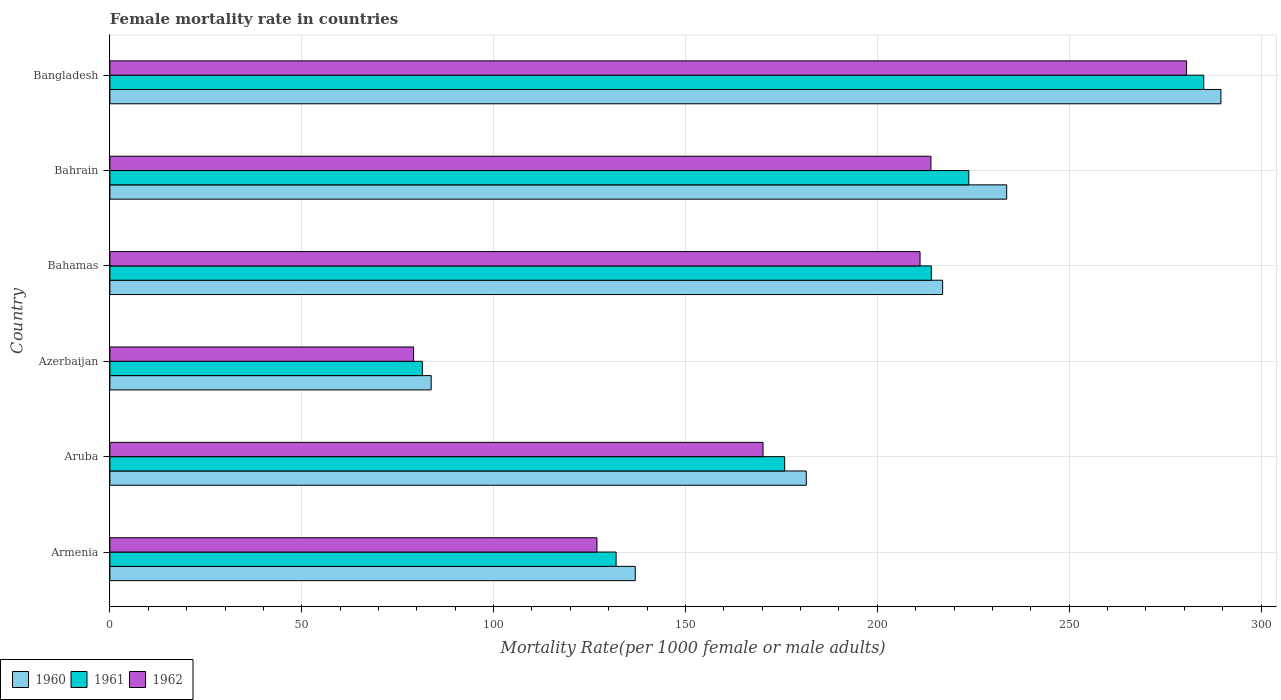How many bars are there on the 4th tick from the top?
Give a very brief answer. 3. How many bars are there on the 3rd tick from the bottom?
Your answer should be compact. 3. What is the label of the 6th group of bars from the top?
Offer a terse response. Armenia. In how many cases, is the number of bars for a given country not equal to the number of legend labels?
Provide a short and direct response. 0. What is the female mortality rate in 1962 in Bahamas?
Offer a very short reply. 211.13. Across all countries, what is the maximum female mortality rate in 1961?
Keep it short and to the point. 285.07. Across all countries, what is the minimum female mortality rate in 1960?
Your answer should be compact. 83.73. In which country was the female mortality rate in 1962 minimum?
Your response must be concise. Azerbaijan. What is the total female mortality rate in 1961 in the graph?
Provide a succinct answer. 1112.19. What is the difference between the female mortality rate in 1960 in Azerbaijan and that in Bangladesh?
Provide a short and direct response. -205.82. What is the difference between the female mortality rate in 1960 in Bahamas and the female mortality rate in 1962 in Armenia?
Ensure brevity in your answer.  90.08. What is the average female mortality rate in 1961 per country?
Offer a terse response. 185.37. What is the difference between the female mortality rate in 1962 and female mortality rate in 1960 in Bangladesh?
Make the answer very short. -8.96. In how many countries, is the female mortality rate in 1962 greater than 20 ?
Your response must be concise. 6. What is the ratio of the female mortality rate in 1962 in Azerbaijan to that in Bahamas?
Provide a short and direct response. 0.37. Is the female mortality rate in 1960 in Armenia less than that in Azerbaijan?
Your answer should be compact. No. What is the difference between the highest and the second highest female mortality rate in 1962?
Provide a short and direct response. 66.62. What is the difference between the highest and the lowest female mortality rate in 1961?
Your response must be concise. 203.64. Is the sum of the female mortality rate in 1962 in Armenia and Azerbaijan greater than the maximum female mortality rate in 1960 across all countries?
Provide a short and direct response. No. Are all the bars in the graph horizontal?
Your answer should be compact. Yes. How many countries are there in the graph?
Ensure brevity in your answer.  6. What is the difference between two consecutive major ticks on the X-axis?
Your answer should be compact. 50. Does the graph contain any zero values?
Offer a terse response. No. Where does the legend appear in the graph?
Give a very brief answer. Bottom left. What is the title of the graph?
Your answer should be compact. Female mortality rate in countries. What is the label or title of the X-axis?
Provide a short and direct response. Mortality Rate(per 1000 female or male adults). What is the label or title of the Y-axis?
Make the answer very short. Country. What is the Mortality Rate(per 1000 female or male adults) of 1960 in Armenia?
Offer a very short reply. 136.92. What is the Mortality Rate(per 1000 female or male adults) of 1961 in Armenia?
Make the answer very short. 131.93. What is the Mortality Rate(per 1000 female or male adults) of 1962 in Armenia?
Keep it short and to the point. 126.93. What is the Mortality Rate(per 1000 female or male adults) of 1960 in Aruba?
Provide a succinct answer. 181.48. What is the Mortality Rate(per 1000 female or male adults) in 1961 in Aruba?
Ensure brevity in your answer.  175.85. What is the Mortality Rate(per 1000 female or male adults) of 1962 in Aruba?
Offer a very short reply. 170.21. What is the Mortality Rate(per 1000 female or male adults) in 1960 in Azerbaijan?
Your answer should be compact. 83.73. What is the Mortality Rate(per 1000 female or male adults) of 1961 in Azerbaijan?
Ensure brevity in your answer.  81.43. What is the Mortality Rate(per 1000 female or male adults) in 1962 in Azerbaijan?
Ensure brevity in your answer.  79.14. What is the Mortality Rate(per 1000 female or male adults) of 1960 in Bahamas?
Give a very brief answer. 217.02. What is the Mortality Rate(per 1000 female or male adults) in 1961 in Bahamas?
Offer a terse response. 214.07. What is the Mortality Rate(per 1000 female or male adults) of 1962 in Bahamas?
Offer a very short reply. 211.13. What is the Mortality Rate(per 1000 female or male adults) in 1960 in Bahrain?
Your response must be concise. 233.71. What is the Mortality Rate(per 1000 female or male adults) in 1961 in Bahrain?
Provide a succinct answer. 223.84. What is the Mortality Rate(per 1000 female or male adults) of 1962 in Bahrain?
Offer a very short reply. 213.97. What is the Mortality Rate(per 1000 female or male adults) of 1960 in Bangladesh?
Keep it short and to the point. 289.55. What is the Mortality Rate(per 1000 female or male adults) in 1961 in Bangladesh?
Provide a short and direct response. 285.07. What is the Mortality Rate(per 1000 female or male adults) of 1962 in Bangladesh?
Keep it short and to the point. 280.59. Across all countries, what is the maximum Mortality Rate(per 1000 female or male adults) of 1960?
Provide a short and direct response. 289.55. Across all countries, what is the maximum Mortality Rate(per 1000 female or male adults) of 1961?
Offer a terse response. 285.07. Across all countries, what is the maximum Mortality Rate(per 1000 female or male adults) in 1962?
Your response must be concise. 280.59. Across all countries, what is the minimum Mortality Rate(per 1000 female or male adults) in 1960?
Offer a terse response. 83.73. Across all countries, what is the minimum Mortality Rate(per 1000 female or male adults) in 1961?
Your answer should be very brief. 81.43. Across all countries, what is the minimum Mortality Rate(per 1000 female or male adults) in 1962?
Provide a succinct answer. 79.14. What is the total Mortality Rate(per 1000 female or male adults) of 1960 in the graph?
Give a very brief answer. 1142.41. What is the total Mortality Rate(per 1000 female or male adults) in 1961 in the graph?
Make the answer very short. 1112.19. What is the total Mortality Rate(per 1000 female or male adults) in 1962 in the graph?
Offer a very short reply. 1081.97. What is the difference between the Mortality Rate(per 1000 female or male adults) in 1960 in Armenia and that in Aruba?
Your response must be concise. -44.57. What is the difference between the Mortality Rate(per 1000 female or male adults) in 1961 in Armenia and that in Aruba?
Offer a very short reply. -43.92. What is the difference between the Mortality Rate(per 1000 female or male adults) in 1962 in Armenia and that in Aruba?
Provide a short and direct response. -43.28. What is the difference between the Mortality Rate(per 1000 female or male adults) of 1960 in Armenia and that in Azerbaijan?
Your answer should be very brief. 53.19. What is the difference between the Mortality Rate(per 1000 female or male adults) of 1961 in Armenia and that in Azerbaijan?
Your answer should be very brief. 50.49. What is the difference between the Mortality Rate(per 1000 female or male adults) of 1962 in Armenia and that in Azerbaijan?
Offer a very short reply. 47.8. What is the difference between the Mortality Rate(per 1000 female or male adults) of 1960 in Armenia and that in Bahamas?
Provide a succinct answer. -80.1. What is the difference between the Mortality Rate(per 1000 female or male adults) of 1961 in Armenia and that in Bahamas?
Provide a short and direct response. -82.15. What is the difference between the Mortality Rate(per 1000 female or male adults) of 1962 in Armenia and that in Bahamas?
Offer a very short reply. -84.2. What is the difference between the Mortality Rate(per 1000 female or male adults) in 1960 in Armenia and that in Bahrain?
Your response must be concise. -96.8. What is the difference between the Mortality Rate(per 1000 female or male adults) of 1961 in Armenia and that in Bahrain?
Provide a succinct answer. -91.92. What is the difference between the Mortality Rate(per 1000 female or male adults) in 1962 in Armenia and that in Bahrain?
Ensure brevity in your answer.  -87.04. What is the difference between the Mortality Rate(per 1000 female or male adults) in 1960 in Armenia and that in Bangladesh?
Your response must be concise. -152.63. What is the difference between the Mortality Rate(per 1000 female or male adults) in 1961 in Armenia and that in Bangladesh?
Offer a very short reply. -153.14. What is the difference between the Mortality Rate(per 1000 female or male adults) of 1962 in Armenia and that in Bangladesh?
Offer a terse response. -153.66. What is the difference between the Mortality Rate(per 1000 female or male adults) of 1960 in Aruba and that in Azerbaijan?
Give a very brief answer. 97.76. What is the difference between the Mortality Rate(per 1000 female or male adults) of 1961 in Aruba and that in Azerbaijan?
Make the answer very short. 94.42. What is the difference between the Mortality Rate(per 1000 female or male adults) in 1962 in Aruba and that in Azerbaijan?
Provide a succinct answer. 91.08. What is the difference between the Mortality Rate(per 1000 female or male adults) in 1960 in Aruba and that in Bahamas?
Offer a very short reply. -35.53. What is the difference between the Mortality Rate(per 1000 female or male adults) of 1961 in Aruba and that in Bahamas?
Provide a short and direct response. -38.23. What is the difference between the Mortality Rate(per 1000 female or male adults) of 1962 in Aruba and that in Bahamas?
Give a very brief answer. -40.92. What is the difference between the Mortality Rate(per 1000 female or male adults) of 1960 in Aruba and that in Bahrain?
Your response must be concise. -52.23. What is the difference between the Mortality Rate(per 1000 female or male adults) of 1961 in Aruba and that in Bahrain?
Give a very brief answer. -47.99. What is the difference between the Mortality Rate(per 1000 female or male adults) in 1962 in Aruba and that in Bahrain?
Keep it short and to the point. -43.76. What is the difference between the Mortality Rate(per 1000 female or male adults) of 1960 in Aruba and that in Bangladesh?
Ensure brevity in your answer.  -108.06. What is the difference between the Mortality Rate(per 1000 female or male adults) in 1961 in Aruba and that in Bangladesh?
Ensure brevity in your answer.  -109.22. What is the difference between the Mortality Rate(per 1000 female or male adults) of 1962 in Aruba and that in Bangladesh?
Ensure brevity in your answer.  -110.38. What is the difference between the Mortality Rate(per 1000 female or male adults) of 1960 in Azerbaijan and that in Bahamas?
Give a very brief answer. -133.29. What is the difference between the Mortality Rate(per 1000 female or male adults) in 1961 in Azerbaijan and that in Bahamas?
Provide a succinct answer. -132.64. What is the difference between the Mortality Rate(per 1000 female or male adults) of 1962 in Azerbaijan and that in Bahamas?
Your response must be concise. -131.99. What is the difference between the Mortality Rate(per 1000 female or male adults) in 1960 in Azerbaijan and that in Bahrain?
Offer a terse response. -149.99. What is the difference between the Mortality Rate(per 1000 female or male adults) of 1961 in Azerbaijan and that in Bahrain?
Ensure brevity in your answer.  -142.41. What is the difference between the Mortality Rate(per 1000 female or male adults) in 1962 in Azerbaijan and that in Bahrain?
Ensure brevity in your answer.  -134.83. What is the difference between the Mortality Rate(per 1000 female or male adults) of 1960 in Azerbaijan and that in Bangladesh?
Your response must be concise. -205.82. What is the difference between the Mortality Rate(per 1000 female or male adults) in 1961 in Azerbaijan and that in Bangladesh?
Provide a short and direct response. -203.64. What is the difference between the Mortality Rate(per 1000 female or male adults) in 1962 in Azerbaijan and that in Bangladesh?
Your answer should be very brief. -201.45. What is the difference between the Mortality Rate(per 1000 female or male adults) of 1960 in Bahamas and that in Bahrain?
Offer a very short reply. -16.7. What is the difference between the Mortality Rate(per 1000 female or male adults) of 1961 in Bahamas and that in Bahrain?
Offer a terse response. -9.77. What is the difference between the Mortality Rate(per 1000 female or male adults) of 1962 in Bahamas and that in Bahrain?
Give a very brief answer. -2.84. What is the difference between the Mortality Rate(per 1000 female or male adults) of 1960 in Bahamas and that in Bangladesh?
Your response must be concise. -72.53. What is the difference between the Mortality Rate(per 1000 female or male adults) in 1961 in Bahamas and that in Bangladesh?
Your answer should be compact. -70.99. What is the difference between the Mortality Rate(per 1000 female or male adults) in 1962 in Bahamas and that in Bangladesh?
Keep it short and to the point. -69.46. What is the difference between the Mortality Rate(per 1000 female or male adults) in 1960 in Bahrain and that in Bangladesh?
Offer a very short reply. -55.84. What is the difference between the Mortality Rate(per 1000 female or male adults) in 1961 in Bahrain and that in Bangladesh?
Keep it short and to the point. -61.23. What is the difference between the Mortality Rate(per 1000 female or male adults) of 1962 in Bahrain and that in Bangladesh?
Provide a succinct answer. -66.62. What is the difference between the Mortality Rate(per 1000 female or male adults) of 1960 in Armenia and the Mortality Rate(per 1000 female or male adults) of 1961 in Aruba?
Offer a very short reply. -38.93. What is the difference between the Mortality Rate(per 1000 female or male adults) of 1960 in Armenia and the Mortality Rate(per 1000 female or male adults) of 1962 in Aruba?
Your response must be concise. -33.3. What is the difference between the Mortality Rate(per 1000 female or male adults) in 1961 in Armenia and the Mortality Rate(per 1000 female or male adults) in 1962 in Aruba?
Provide a short and direct response. -38.29. What is the difference between the Mortality Rate(per 1000 female or male adults) in 1960 in Armenia and the Mortality Rate(per 1000 female or male adults) in 1961 in Azerbaijan?
Offer a very short reply. 55.48. What is the difference between the Mortality Rate(per 1000 female or male adults) of 1960 in Armenia and the Mortality Rate(per 1000 female or male adults) of 1962 in Azerbaijan?
Ensure brevity in your answer.  57.78. What is the difference between the Mortality Rate(per 1000 female or male adults) of 1961 in Armenia and the Mortality Rate(per 1000 female or male adults) of 1962 in Azerbaijan?
Your response must be concise. 52.79. What is the difference between the Mortality Rate(per 1000 female or male adults) in 1960 in Armenia and the Mortality Rate(per 1000 female or male adults) in 1961 in Bahamas?
Your answer should be very brief. -77.16. What is the difference between the Mortality Rate(per 1000 female or male adults) of 1960 in Armenia and the Mortality Rate(per 1000 female or male adults) of 1962 in Bahamas?
Offer a very short reply. -74.22. What is the difference between the Mortality Rate(per 1000 female or male adults) of 1961 in Armenia and the Mortality Rate(per 1000 female or male adults) of 1962 in Bahamas?
Offer a very short reply. -79.21. What is the difference between the Mortality Rate(per 1000 female or male adults) of 1960 in Armenia and the Mortality Rate(per 1000 female or male adults) of 1961 in Bahrain?
Provide a short and direct response. -86.92. What is the difference between the Mortality Rate(per 1000 female or male adults) of 1960 in Armenia and the Mortality Rate(per 1000 female or male adults) of 1962 in Bahrain?
Offer a very short reply. -77.05. What is the difference between the Mortality Rate(per 1000 female or male adults) of 1961 in Armenia and the Mortality Rate(per 1000 female or male adults) of 1962 in Bahrain?
Your answer should be very brief. -82.04. What is the difference between the Mortality Rate(per 1000 female or male adults) of 1960 in Armenia and the Mortality Rate(per 1000 female or male adults) of 1961 in Bangladesh?
Your answer should be compact. -148.15. What is the difference between the Mortality Rate(per 1000 female or male adults) of 1960 in Armenia and the Mortality Rate(per 1000 female or male adults) of 1962 in Bangladesh?
Ensure brevity in your answer.  -143.67. What is the difference between the Mortality Rate(per 1000 female or male adults) in 1961 in Armenia and the Mortality Rate(per 1000 female or male adults) in 1962 in Bangladesh?
Your answer should be very brief. -148.66. What is the difference between the Mortality Rate(per 1000 female or male adults) in 1960 in Aruba and the Mortality Rate(per 1000 female or male adults) in 1961 in Azerbaijan?
Provide a short and direct response. 100.05. What is the difference between the Mortality Rate(per 1000 female or male adults) of 1960 in Aruba and the Mortality Rate(per 1000 female or male adults) of 1962 in Azerbaijan?
Keep it short and to the point. 102.35. What is the difference between the Mortality Rate(per 1000 female or male adults) in 1961 in Aruba and the Mortality Rate(per 1000 female or male adults) in 1962 in Azerbaijan?
Provide a succinct answer. 96.71. What is the difference between the Mortality Rate(per 1000 female or male adults) of 1960 in Aruba and the Mortality Rate(per 1000 female or male adults) of 1961 in Bahamas?
Keep it short and to the point. -32.59. What is the difference between the Mortality Rate(per 1000 female or male adults) in 1960 in Aruba and the Mortality Rate(per 1000 female or male adults) in 1962 in Bahamas?
Provide a short and direct response. -29.65. What is the difference between the Mortality Rate(per 1000 female or male adults) of 1961 in Aruba and the Mortality Rate(per 1000 female or male adults) of 1962 in Bahamas?
Your answer should be compact. -35.28. What is the difference between the Mortality Rate(per 1000 female or male adults) in 1960 in Aruba and the Mortality Rate(per 1000 female or male adults) in 1961 in Bahrain?
Your response must be concise. -42.36. What is the difference between the Mortality Rate(per 1000 female or male adults) in 1960 in Aruba and the Mortality Rate(per 1000 female or male adults) in 1962 in Bahrain?
Make the answer very short. -32.48. What is the difference between the Mortality Rate(per 1000 female or male adults) in 1961 in Aruba and the Mortality Rate(per 1000 female or male adults) in 1962 in Bahrain?
Provide a short and direct response. -38.12. What is the difference between the Mortality Rate(per 1000 female or male adults) in 1960 in Aruba and the Mortality Rate(per 1000 female or male adults) in 1961 in Bangladesh?
Offer a terse response. -103.58. What is the difference between the Mortality Rate(per 1000 female or male adults) of 1960 in Aruba and the Mortality Rate(per 1000 female or male adults) of 1962 in Bangladesh?
Provide a short and direct response. -99.1. What is the difference between the Mortality Rate(per 1000 female or male adults) of 1961 in Aruba and the Mortality Rate(per 1000 female or male adults) of 1962 in Bangladesh?
Ensure brevity in your answer.  -104.74. What is the difference between the Mortality Rate(per 1000 female or male adults) in 1960 in Azerbaijan and the Mortality Rate(per 1000 female or male adults) in 1961 in Bahamas?
Offer a very short reply. -130.35. What is the difference between the Mortality Rate(per 1000 female or male adults) in 1960 in Azerbaijan and the Mortality Rate(per 1000 female or male adults) in 1962 in Bahamas?
Give a very brief answer. -127.4. What is the difference between the Mortality Rate(per 1000 female or male adults) of 1961 in Azerbaijan and the Mortality Rate(per 1000 female or male adults) of 1962 in Bahamas?
Ensure brevity in your answer.  -129.7. What is the difference between the Mortality Rate(per 1000 female or male adults) in 1960 in Azerbaijan and the Mortality Rate(per 1000 female or male adults) in 1961 in Bahrain?
Your answer should be compact. -140.11. What is the difference between the Mortality Rate(per 1000 female or male adults) in 1960 in Azerbaijan and the Mortality Rate(per 1000 female or male adults) in 1962 in Bahrain?
Provide a succinct answer. -130.24. What is the difference between the Mortality Rate(per 1000 female or male adults) of 1961 in Azerbaijan and the Mortality Rate(per 1000 female or male adults) of 1962 in Bahrain?
Keep it short and to the point. -132.54. What is the difference between the Mortality Rate(per 1000 female or male adults) in 1960 in Azerbaijan and the Mortality Rate(per 1000 female or male adults) in 1961 in Bangladesh?
Keep it short and to the point. -201.34. What is the difference between the Mortality Rate(per 1000 female or male adults) of 1960 in Azerbaijan and the Mortality Rate(per 1000 female or male adults) of 1962 in Bangladesh?
Give a very brief answer. -196.86. What is the difference between the Mortality Rate(per 1000 female or male adults) of 1961 in Azerbaijan and the Mortality Rate(per 1000 female or male adults) of 1962 in Bangladesh?
Your answer should be compact. -199.16. What is the difference between the Mortality Rate(per 1000 female or male adults) in 1960 in Bahamas and the Mortality Rate(per 1000 female or male adults) in 1961 in Bahrain?
Your answer should be compact. -6.82. What is the difference between the Mortality Rate(per 1000 female or male adults) of 1960 in Bahamas and the Mortality Rate(per 1000 female or male adults) of 1962 in Bahrain?
Ensure brevity in your answer.  3.05. What is the difference between the Mortality Rate(per 1000 female or male adults) of 1961 in Bahamas and the Mortality Rate(per 1000 female or male adults) of 1962 in Bahrain?
Offer a terse response. 0.11. What is the difference between the Mortality Rate(per 1000 female or male adults) of 1960 in Bahamas and the Mortality Rate(per 1000 female or male adults) of 1961 in Bangladesh?
Provide a short and direct response. -68.05. What is the difference between the Mortality Rate(per 1000 female or male adults) in 1960 in Bahamas and the Mortality Rate(per 1000 female or male adults) in 1962 in Bangladesh?
Make the answer very short. -63.57. What is the difference between the Mortality Rate(per 1000 female or male adults) of 1961 in Bahamas and the Mortality Rate(per 1000 female or male adults) of 1962 in Bangladesh?
Ensure brevity in your answer.  -66.51. What is the difference between the Mortality Rate(per 1000 female or male adults) in 1960 in Bahrain and the Mortality Rate(per 1000 female or male adults) in 1961 in Bangladesh?
Your answer should be compact. -51.35. What is the difference between the Mortality Rate(per 1000 female or male adults) in 1960 in Bahrain and the Mortality Rate(per 1000 female or male adults) in 1962 in Bangladesh?
Provide a short and direct response. -46.88. What is the difference between the Mortality Rate(per 1000 female or male adults) in 1961 in Bahrain and the Mortality Rate(per 1000 female or male adults) in 1962 in Bangladesh?
Provide a short and direct response. -56.75. What is the average Mortality Rate(per 1000 female or male adults) in 1960 per country?
Offer a very short reply. 190.4. What is the average Mortality Rate(per 1000 female or male adults) in 1961 per country?
Provide a short and direct response. 185.37. What is the average Mortality Rate(per 1000 female or male adults) of 1962 per country?
Offer a terse response. 180.33. What is the difference between the Mortality Rate(per 1000 female or male adults) of 1960 and Mortality Rate(per 1000 female or male adults) of 1961 in Armenia?
Your answer should be very brief. 4.99. What is the difference between the Mortality Rate(per 1000 female or male adults) of 1960 and Mortality Rate(per 1000 female or male adults) of 1962 in Armenia?
Make the answer very short. 9.98. What is the difference between the Mortality Rate(per 1000 female or male adults) in 1961 and Mortality Rate(per 1000 female or male adults) in 1962 in Armenia?
Provide a succinct answer. 4.99. What is the difference between the Mortality Rate(per 1000 female or male adults) in 1960 and Mortality Rate(per 1000 female or male adults) in 1961 in Aruba?
Your answer should be compact. 5.63. What is the difference between the Mortality Rate(per 1000 female or male adults) of 1960 and Mortality Rate(per 1000 female or male adults) of 1962 in Aruba?
Offer a very short reply. 11.27. What is the difference between the Mortality Rate(per 1000 female or male adults) in 1961 and Mortality Rate(per 1000 female or male adults) in 1962 in Aruba?
Your answer should be compact. 5.64. What is the difference between the Mortality Rate(per 1000 female or male adults) in 1960 and Mortality Rate(per 1000 female or male adults) in 1961 in Azerbaijan?
Your answer should be very brief. 2.29. What is the difference between the Mortality Rate(per 1000 female or male adults) in 1960 and Mortality Rate(per 1000 female or male adults) in 1962 in Azerbaijan?
Your answer should be compact. 4.59. What is the difference between the Mortality Rate(per 1000 female or male adults) of 1961 and Mortality Rate(per 1000 female or male adults) of 1962 in Azerbaijan?
Your answer should be compact. 2.29. What is the difference between the Mortality Rate(per 1000 female or male adults) in 1960 and Mortality Rate(per 1000 female or male adults) in 1961 in Bahamas?
Give a very brief answer. 2.94. What is the difference between the Mortality Rate(per 1000 female or male adults) of 1960 and Mortality Rate(per 1000 female or male adults) of 1962 in Bahamas?
Make the answer very short. 5.88. What is the difference between the Mortality Rate(per 1000 female or male adults) in 1961 and Mortality Rate(per 1000 female or male adults) in 1962 in Bahamas?
Make the answer very short. 2.94. What is the difference between the Mortality Rate(per 1000 female or male adults) in 1960 and Mortality Rate(per 1000 female or male adults) in 1961 in Bahrain?
Your answer should be compact. 9.87. What is the difference between the Mortality Rate(per 1000 female or male adults) in 1960 and Mortality Rate(per 1000 female or male adults) in 1962 in Bahrain?
Your answer should be compact. 19.74. What is the difference between the Mortality Rate(per 1000 female or male adults) in 1961 and Mortality Rate(per 1000 female or male adults) in 1962 in Bahrain?
Provide a short and direct response. 9.87. What is the difference between the Mortality Rate(per 1000 female or male adults) in 1960 and Mortality Rate(per 1000 female or male adults) in 1961 in Bangladesh?
Make the answer very short. 4.48. What is the difference between the Mortality Rate(per 1000 female or male adults) of 1960 and Mortality Rate(per 1000 female or male adults) of 1962 in Bangladesh?
Provide a succinct answer. 8.96. What is the difference between the Mortality Rate(per 1000 female or male adults) of 1961 and Mortality Rate(per 1000 female or male adults) of 1962 in Bangladesh?
Give a very brief answer. 4.48. What is the ratio of the Mortality Rate(per 1000 female or male adults) of 1960 in Armenia to that in Aruba?
Your answer should be compact. 0.75. What is the ratio of the Mortality Rate(per 1000 female or male adults) in 1961 in Armenia to that in Aruba?
Your answer should be compact. 0.75. What is the ratio of the Mortality Rate(per 1000 female or male adults) of 1962 in Armenia to that in Aruba?
Keep it short and to the point. 0.75. What is the ratio of the Mortality Rate(per 1000 female or male adults) of 1960 in Armenia to that in Azerbaijan?
Your answer should be compact. 1.64. What is the ratio of the Mortality Rate(per 1000 female or male adults) of 1961 in Armenia to that in Azerbaijan?
Provide a succinct answer. 1.62. What is the ratio of the Mortality Rate(per 1000 female or male adults) of 1962 in Armenia to that in Azerbaijan?
Make the answer very short. 1.6. What is the ratio of the Mortality Rate(per 1000 female or male adults) of 1960 in Armenia to that in Bahamas?
Offer a terse response. 0.63. What is the ratio of the Mortality Rate(per 1000 female or male adults) in 1961 in Armenia to that in Bahamas?
Ensure brevity in your answer.  0.62. What is the ratio of the Mortality Rate(per 1000 female or male adults) of 1962 in Armenia to that in Bahamas?
Provide a short and direct response. 0.6. What is the ratio of the Mortality Rate(per 1000 female or male adults) of 1960 in Armenia to that in Bahrain?
Make the answer very short. 0.59. What is the ratio of the Mortality Rate(per 1000 female or male adults) of 1961 in Armenia to that in Bahrain?
Offer a very short reply. 0.59. What is the ratio of the Mortality Rate(per 1000 female or male adults) in 1962 in Armenia to that in Bahrain?
Provide a succinct answer. 0.59. What is the ratio of the Mortality Rate(per 1000 female or male adults) of 1960 in Armenia to that in Bangladesh?
Provide a succinct answer. 0.47. What is the ratio of the Mortality Rate(per 1000 female or male adults) of 1961 in Armenia to that in Bangladesh?
Provide a short and direct response. 0.46. What is the ratio of the Mortality Rate(per 1000 female or male adults) in 1962 in Armenia to that in Bangladesh?
Offer a terse response. 0.45. What is the ratio of the Mortality Rate(per 1000 female or male adults) of 1960 in Aruba to that in Azerbaijan?
Offer a terse response. 2.17. What is the ratio of the Mortality Rate(per 1000 female or male adults) of 1961 in Aruba to that in Azerbaijan?
Provide a short and direct response. 2.16. What is the ratio of the Mortality Rate(per 1000 female or male adults) in 1962 in Aruba to that in Azerbaijan?
Ensure brevity in your answer.  2.15. What is the ratio of the Mortality Rate(per 1000 female or male adults) of 1960 in Aruba to that in Bahamas?
Your answer should be very brief. 0.84. What is the ratio of the Mortality Rate(per 1000 female or male adults) of 1961 in Aruba to that in Bahamas?
Offer a terse response. 0.82. What is the ratio of the Mortality Rate(per 1000 female or male adults) of 1962 in Aruba to that in Bahamas?
Give a very brief answer. 0.81. What is the ratio of the Mortality Rate(per 1000 female or male adults) in 1960 in Aruba to that in Bahrain?
Provide a short and direct response. 0.78. What is the ratio of the Mortality Rate(per 1000 female or male adults) in 1961 in Aruba to that in Bahrain?
Provide a succinct answer. 0.79. What is the ratio of the Mortality Rate(per 1000 female or male adults) in 1962 in Aruba to that in Bahrain?
Your answer should be very brief. 0.8. What is the ratio of the Mortality Rate(per 1000 female or male adults) in 1960 in Aruba to that in Bangladesh?
Ensure brevity in your answer.  0.63. What is the ratio of the Mortality Rate(per 1000 female or male adults) of 1961 in Aruba to that in Bangladesh?
Provide a succinct answer. 0.62. What is the ratio of the Mortality Rate(per 1000 female or male adults) in 1962 in Aruba to that in Bangladesh?
Provide a short and direct response. 0.61. What is the ratio of the Mortality Rate(per 1000 female or male adults) in 1960 in Azerbaijan to that in Bahamas?
Your response must be concise. 0.39. What is the ratio of the Mortality Rate(per 1000 female or male adults) in 1961 in Azerbaijan to that in Bahamas?
Your answer should be compact. 0.38. What is the ratio of the Mortality Rate(per 1000 female or male adults) of 1962 in Azerbaijan to that in Bahamas?
Provide a short and direct response. 0.37. What is the ratio of the Mortality Rate(per 1000 female or male adults) in 1960 in Azerbaijan to that in Bahrain?
Give a very brief answer. 0.36. What is the ratio of the Mortality Rate(per 1000 female or male adults) of 1961 in Azerbaijan to that in Bahrain?
Your response must be concise. 0.36. What is the ratio of the Mortality Rate(per 1000 female or male adults) in 1962 in Azerbaijan to that in Bahrain?
Provide a succinct answer. 0.37. What is the ratio of the Mortality Rate(per 1000 female or male adults) of 1960 in Azerbaijan to that in Bangladesh?
Your response must be concise. 0.29. What is the ratio of the Mortality Rate(per 1000 female or male adults) in 1961 in Azerbaijan to that in Bangladesh?
Offer a very short reply. 0.29. What is the ratio of the Mortality Rate(per 1000 female or male adults) in 1962 in Azerbaijan to that in Bangladesh?
Offer a terse response. 0.28. What is the ratio of the Mortality Rate(per 1000 female or male adults) in 1961 in Bahamas to that in Bahrain?
Make the answer very short. 0.96. What is the ratio of the Mortality Rate(per 1000 female or male adults) of 1962 in Bahamas to that in Bahrain?
Give a very brief answer. 0.99. What is the ratio of the Mortality Rate(per 1000 female or male adults) in 1960 in Bahamas to that in Bangladesh?
Ensure brevity in your answer.  0.75. What is the ratio of the Mortality Rate(per 1000 female or male adults) of 1961 in Bahamas to that in Bangladesh?
Your answer should be compact. 0.75. What is the ratio of the Mortality Rate(per 1000 female or male adults) of 1962 in Bahamas to that in Bangladesh?
Keep it short and to the point. 0.75. What is the ratio of the Mortality Rate(per 1000 female or male adults) in 1960 in Bahrain to that in Bangladesh?
Your response must be concise. 0.81. What is the ratio of the Mortality Rate(per 1000 female or male adults) of 1961 in Bahrain to that in Bangladesh?
Give a very brief answer. 0.79. What is the ratio of the Mortality Rate(per 1000 female or male adults) of 1962 in Bahrain to that in Bangladesh?
Provide a short and direct response. 0.76. What is the difference between the highest and the second highest Mortality Rate(per 1000 female or male adults) in 1960?
Your answer should be compact. 55.84. What is the difference between the highest and the second highest Mortality Rate(per 1000 female or male adults) of 1961?
Ensure brevity in your answer.  61.23. What is the difference between the highest and the second highest Mortality Rate(per 1000 female or male adults) in 1962?
Provide a succinct answer. 66.62. What is the difference between the highest and the lowest Mortality Rate(per 1000 female or male adults) of 1960?
Your answer should be compact. 205.82. What is the difference between the highest and the lowest Mortality Rate(per 1000 female or male adults) of 1961?
Make the answer very short. 203.64. What is the difference between the highest and the lowest Mortality Rate(per 1000 female or male adults) of 1962?
Offer a very short reply. 201.45. 